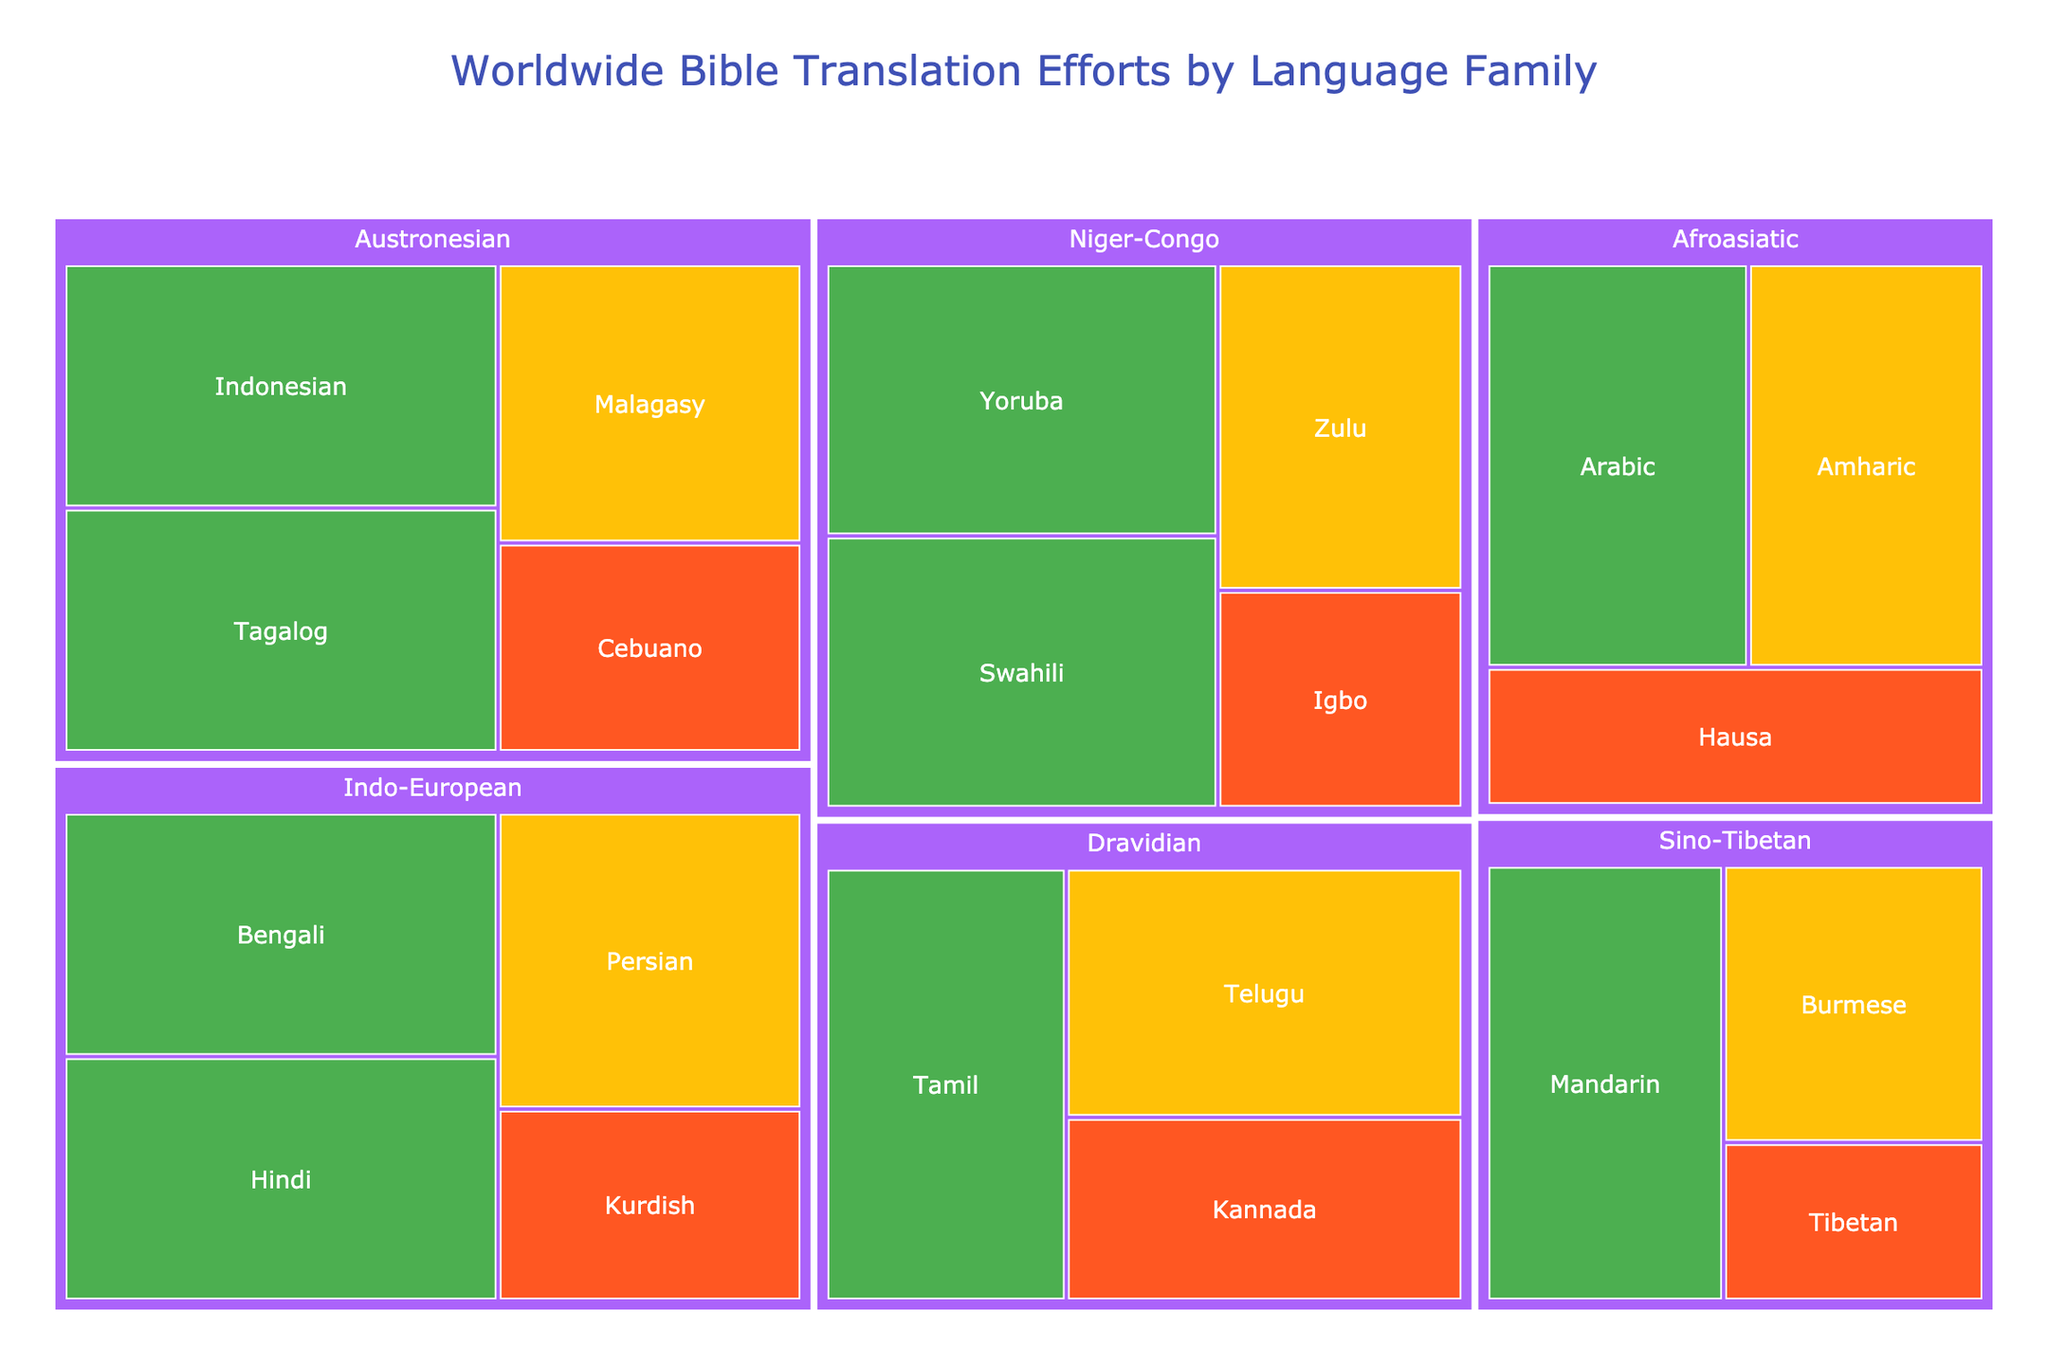What is the title of the treemap? The title of the treemap is displayed at the top of the figure. It clearly states the main topic that the treemap represents, which is the status of worldwide Bible translation efforts categorized by language family.
Answer: Worldwide Bible Translation Efforts by Language Family Which language family has the largest number of languages with complete Bible translations? By observing the colored sections representing different completion statuses, the Niger-Congo family has a notable number of rectangles with the color indicating "Complete," reflecting the highest quantity of fully translated languages in this family.
Answer: Niger-Congo What is the completion status of the Kannada Bible translation? To find the completion status of Kannada, locate the Dravidian language family and then the Kannada language within that family. The color for Kannada indicates "Partial."
Answer: Partial Out of the languages under the Austronesian family, which language has the most advanced translation effort among those not yet complete? In the Austronesian language family, compare the sizes of the rectangles representing languages with "In Progress" or "Partial" status. Malagasy has the translation effort closest to completion, indicated by 80%.
Answer: Malagasy Compare the translation efforts between Persian and Hausa. Which one has made more progress? Locate the rectangles for Persian under the Indo-European family and Hausa under the Afroasiatic family. Persian is "In Progress" with an 85% effort, while Hausa is "Partial" with 65%. Therefore, Persian has made more progress.
Answer: Persian How many languages in the Sino-Tibetan family have the Bible translation marked as "Complete"? Look for the Sino-Tibetan language family in the treemap and count the rectangles with the color indicating "Complete." In this case, only Mandarin has a completed translation.
Answer: 1 Which language family has the highest average translation effort percentage for "In Progress" languages? To find the average, we sum the percentages for "In Progress" languages within each family and divide by the number of such languages. Comparing families: 
- Niger-Congo: (75%)/1 = 75%
- Austronesian: (80%)/1 = 80%
- Sino-Tibetan: (70%)/1 = 70%
- Indo-European: (85%)/1 = 85%
- Afroasiatic: (90%)/1 = 90%
- Dravidian: (95%)/1 = 95%
The Dravidian family has the highest average of 95%.
Answer: Dravidian Identify the language with the lowest translation effort among the Dravidian language family. Within the Dravidian family, find the rectangles and compare their translation percentages. Kannada, with a translation effort of 70%, has the lowest among them.
Answer: Kannada What is the combined translation effort of Tagalog and Cebuano? Add the translation efforts of Tagalog (100%) and Cebuano (60%) by locating them under the Austronesian family: 100% + 60% = 160%.
Answer: 160% Which language family has more languages with "Partial" completion status: Indo-European or Afroasiatic? Count the rectangles with the "Partial" color in each language family. Indo-European has one (Kurdish) and Afroasiatic has one (Hausa). Therefore, both families have an equal count in this status.
Answer: Equal 